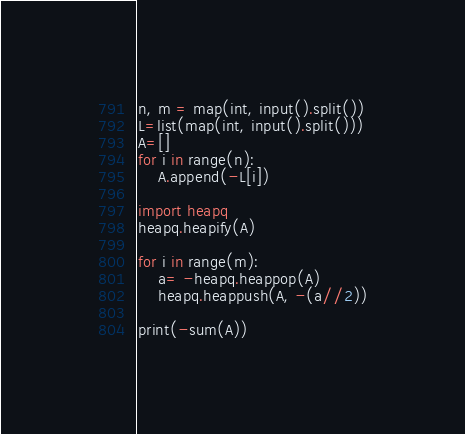<code> <loc_0><loc_0><loc_500><loc_500><_Python_>n, m = map(int, input().split())
L=list(map(int, input().split()))
A=[]
for i in range(n):
	A.append(-L[i])

import heapq
heapq.heapify(A)

for i in range(m):
	a= -heapq.heappop(A)
	heapq.heappush(A, -(a//2))

print(-sum(A))</code> 